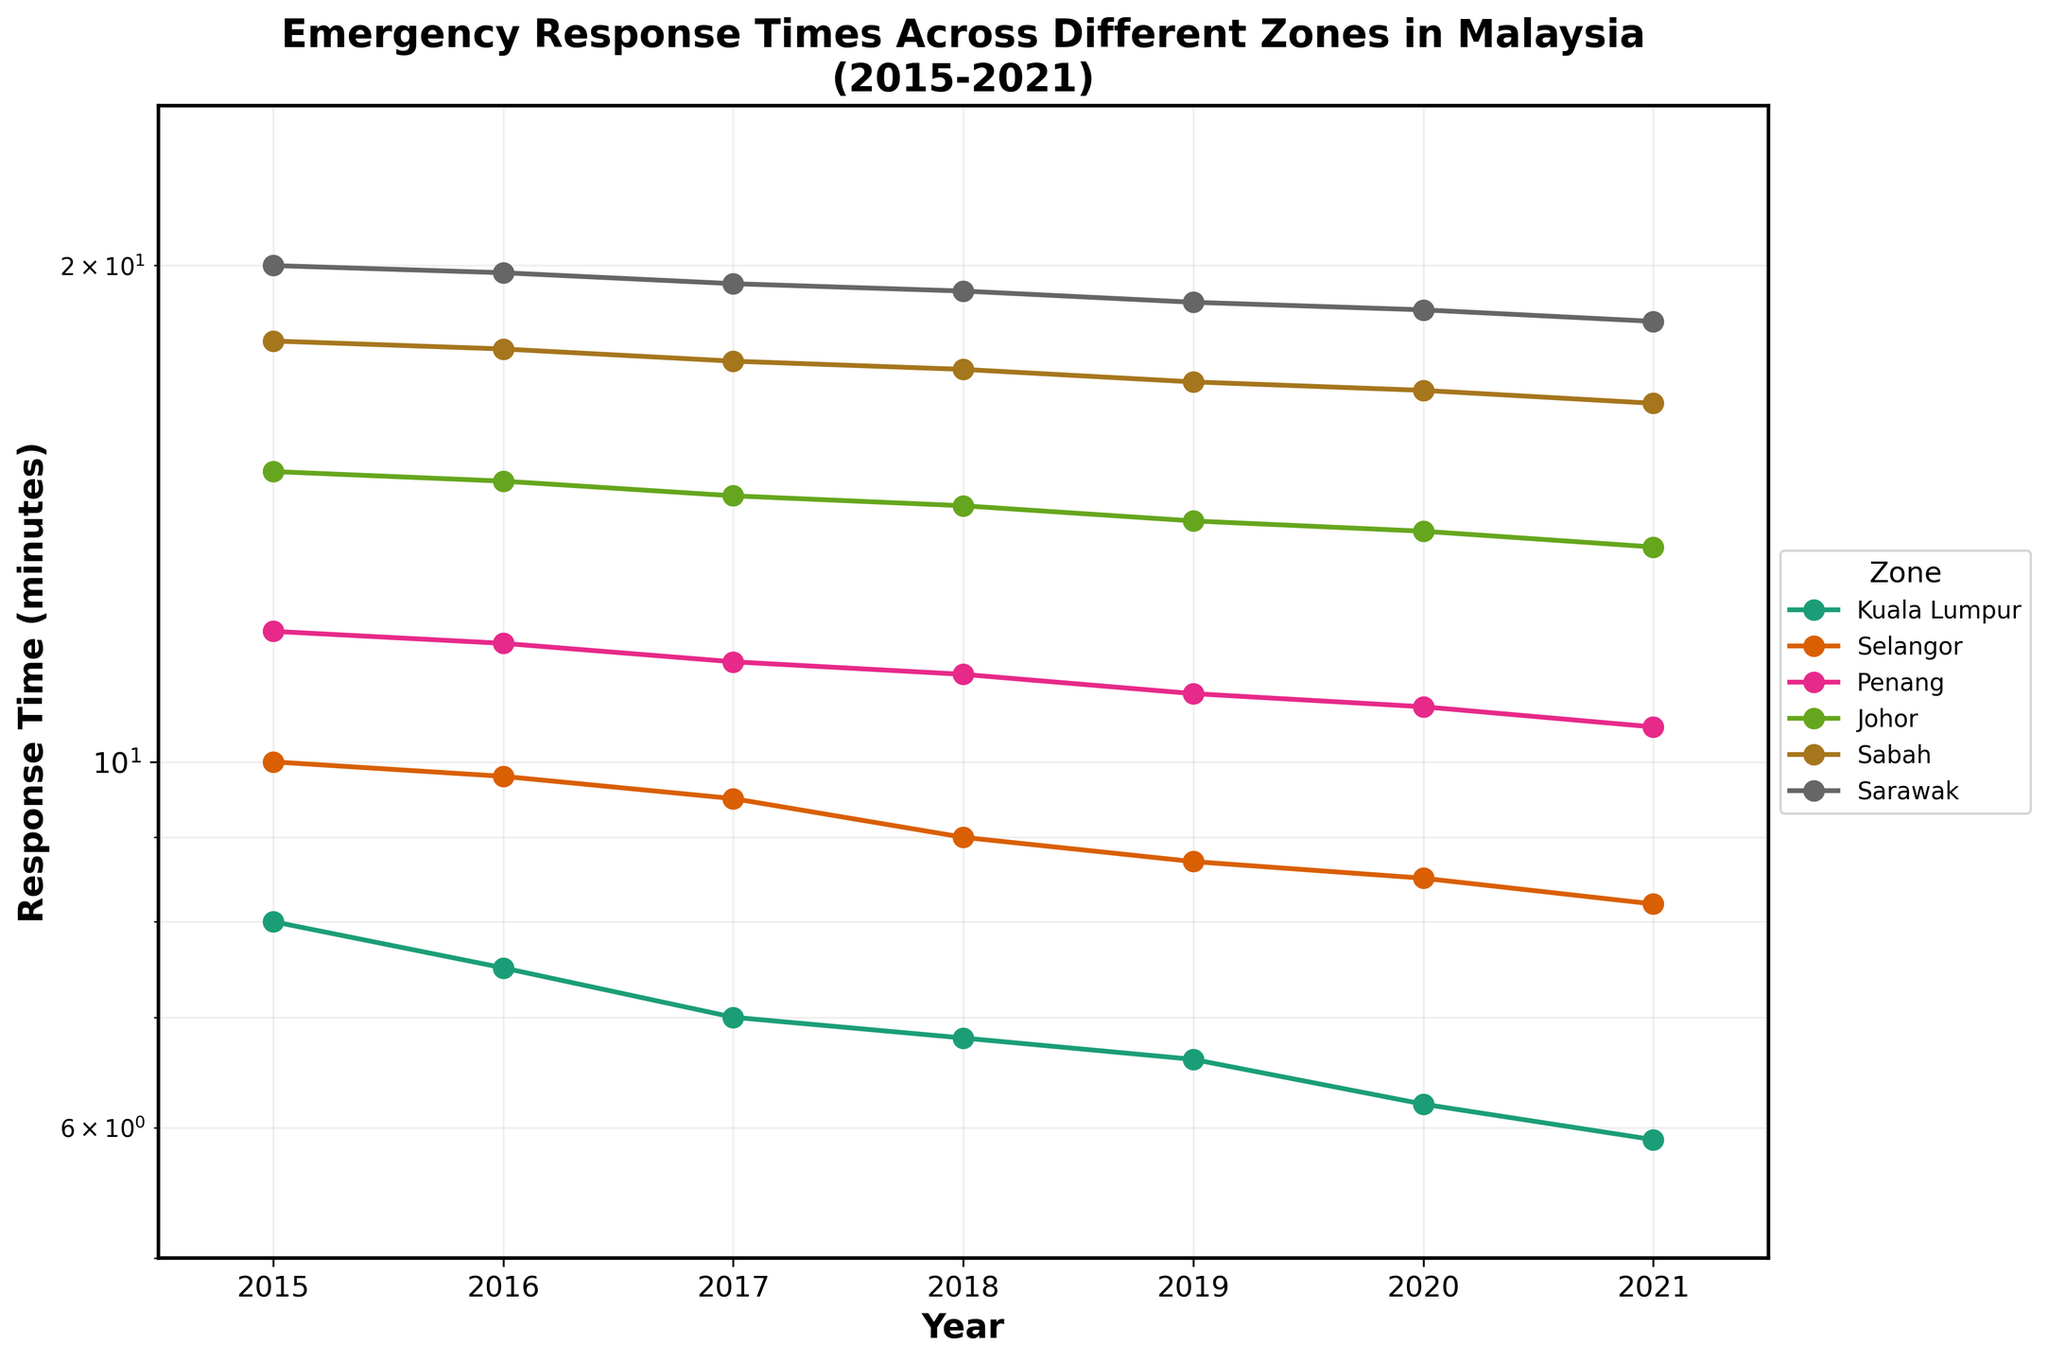What zone has the highest response time in 2021? To identify the highest response time in 2021, look at the points representing the year 2021 for each zone on the plot. The point for Sarawak is the highest on the y-axis.
Answer: Sarawak Which zone showed the greatest decrease in response time from 2015 to 2021? Compare the difference in response times from 2015 to 2021 for each zone. Sarawak has the largest numerical difference, going from 20 to 18.5, a decrease of 1.5 minutes.
Answer: Sarawak Is the response time trend increasing or decreasing for Kuala Lumpur from 2015 to 2021? Examine the line for Kuala Lumpur from 2015 to 2021. The trend is downward, showing a decrease in response time.
Answer: Decreasing Which zone has the most stable (least variable) response time trend over the years? Look for the zone with the least fluctuation in its line. Kuala Lumpur's line is the most stable, showing a consistent downward trend without significant variance between years.
Answer: Kuala Lumpur How many zones have a response time below 10 minutes in 2021? Check each zone's response time for the year 2021 on the plot. Only Kuala Lumpur and Selangor fall below 10 minutes.
Answer: 2 In which year did Selangor’s response time drop below 9 minutes? Track Selangor’s response time line and see when it first drops below the 9-minute mark. In 2019, the response time for Selangor is 8.7 minutes.
Answer: 2019 How does the response time for Johor in 2017 compare to Penang in 2017? Locate Johor's and Penang's response times for 2017 on the plot. Johor's response time is 14.5 minutes, and Penang's is 11.5 minutes. Johor's response time is higher.
Answer: Johor's is higher What's the average response time for Sabah from 2015 to 2021? Add up the response times for Sabah for all the years and divide by the number of years. (18 + 17.8 + 17.5 + 17.3 + 17 + 16.8 + 16.5) / 7 = 17.12857.
Answer: 17.13 Which zone has the steepest slope on the log scale plot? Identify the line with the steepest downward slope. Sarawak shows the steepest decline across the years on the log scale plot.
Answer: Sarawak 